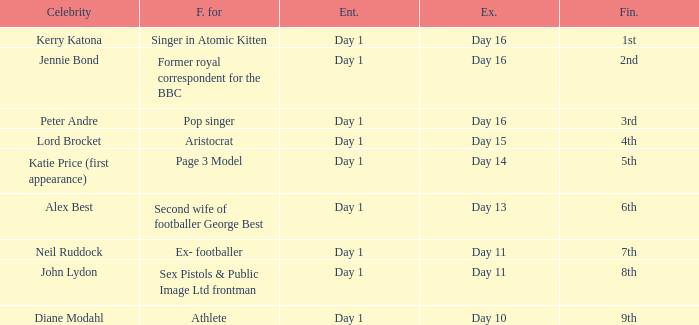Name who was famous for finished in 9th Athlete. 